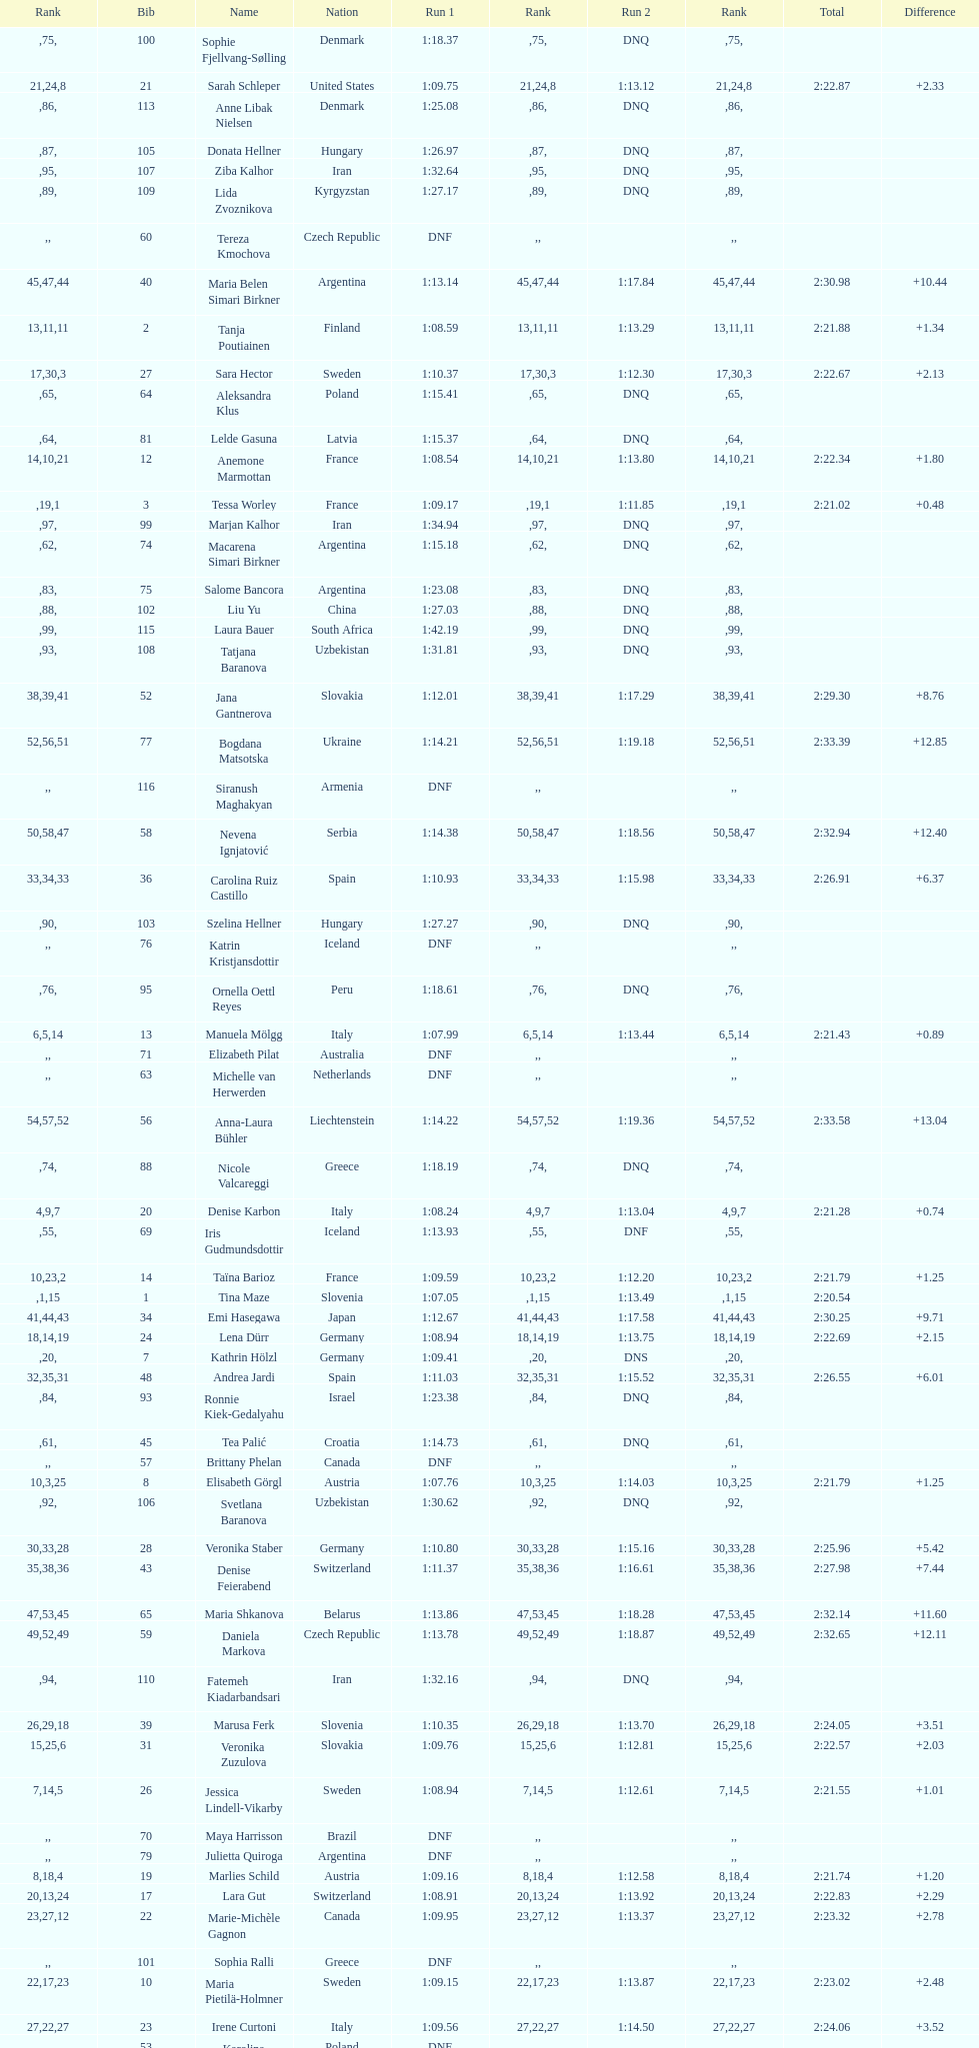Who was ranked immediately after federica brignone? Tessa Worley. 